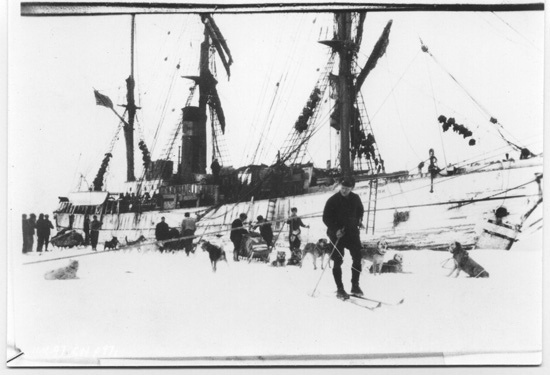Describe the objects in this image and their specific colors. I can see boat in white, lightgray, gray, black, and darkgray tones, people in white, black, gray, lightgray, and darkgray tones, dog in white, gray, darkgray, black, and lightgray tones, people in white, gray, black, darkgray, and lightgray tones, and people in white, gray, black, darkgray, and lightgray tones in this image. 